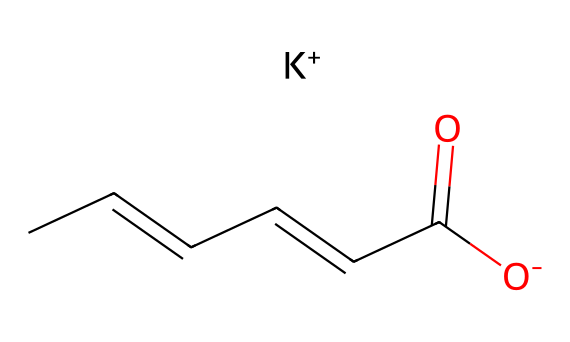What is the main functional group present in potassium sorbate? The chemical structure features a carboxylate group, identifiable by the -C(=O)[O-] portion, which is characteristic of acids and their salts.
Answer: carboxylate How many carbon atoms are in potassium sorbate? The SMILES representation indicates there are 6 carbon atoms in total, which can be counted from the longest chain and functional group.
Answer: 6 What does the presence of the potassium ion suggest about this compound? The inclusion of [K+] signifies that potassium sorbate is a salt, specifically a potassium salt of sorbic acid, which alters its solubility and preservation properties.
Answer: it is a salt What type of compound is potassium sorbate primarily used for? The chemical is primarily used in preserving food, cosmetics, and wooden instruments, indicating its role as a preservative.
Answer: preservative How does the unsaturation in the carbon chain contribute to the reactivity of potassium sorbate? The double bonds in the carbon chain (CC=CC=) suggest that the compound is more reactive due to the presence of unsaturation, influencing its preservation ability.
Answer: more reactive What role does the carboxylate group play in the function of potassium sorbate? The carboxylate group contributes to its antimicrobial properties, allowing it to inhibit mold and yeast growth effectively.
Answer: antimicrobial properties 